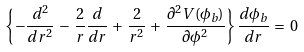Convert formula to latex. <formula><loc_0><loc_0><loc_500><loc_500>\left \{ - \frac { d ^ { 2 } } { d r ^ { 2 } } \, - \, \frac { 2 } { r } \frac { d } { d r } \, + \, \frac { 2 } { r ^ { 2 } } \, + \, \frac { \partial ^ { 2 } V ( \phi _ { b } ) } { \partial \phi ^ { 2 } } \right \} \frac { d \phi _ { b } } { d r } \, = \, 0</formula> 